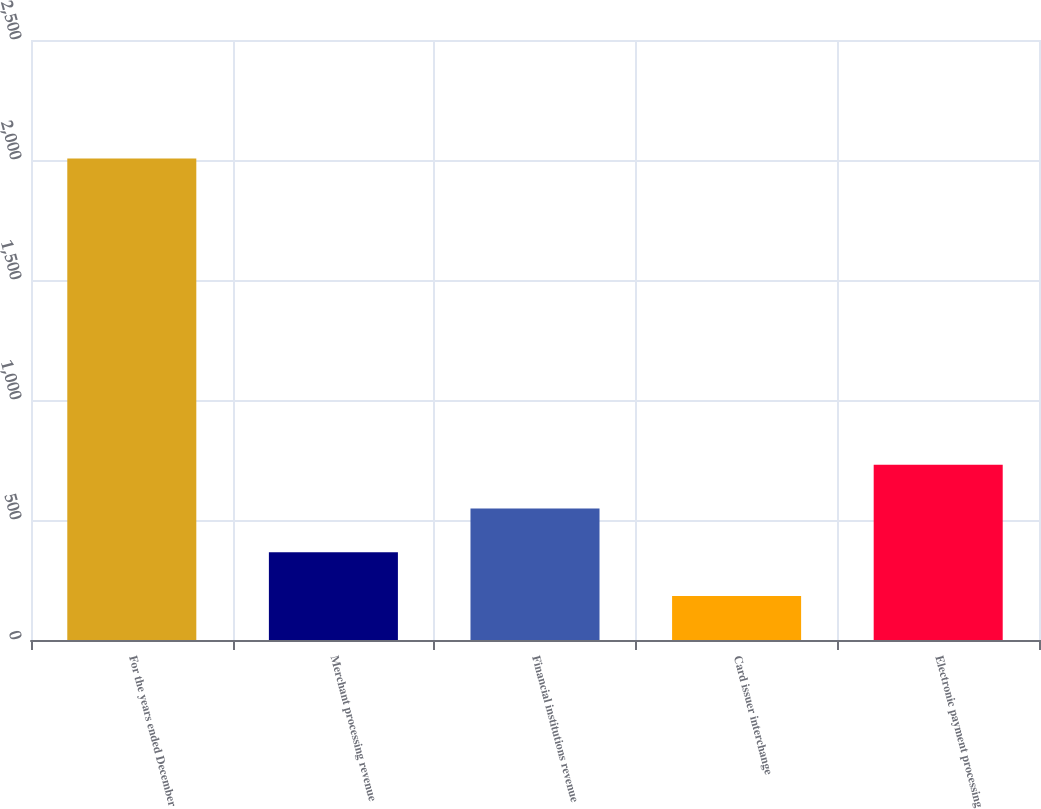<chart> <loc_0><loc_0><loc_500><loc_500><bar_chart><fcel>For the years ended December<fcel>Merchant processing revenue<fcel>Financial institutions revenue<fcel>Card issuer interchange<fcel>Electronic payment processing<nl><fcel>2006<fcel>365.3<fcel>547.6<fcel>183<fcel>729.9<nl></chart> 